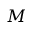Convert formula to latex. <formula><loc_0><loc_0><loc_500><loc_500>M</formula> 